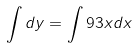Convert formula to latex. <formula><loc_0><loc_0><loc_500><loc_500>\int d y = \int 9 3 x d x</formula> 